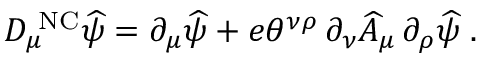<formula> <loc_0><loc_0><loc_500><loc_500>D _ { \mu } ^ { N C } \widehat { \psi } = \partial _ { \mu } \widehat { \psi } + e \theta ^ { \nu \rho } \, \partial _ { \nu } \widehat { A } _ { \mu } \, \partial _ { \rho } \widehat { \psi } \, .</formula> 